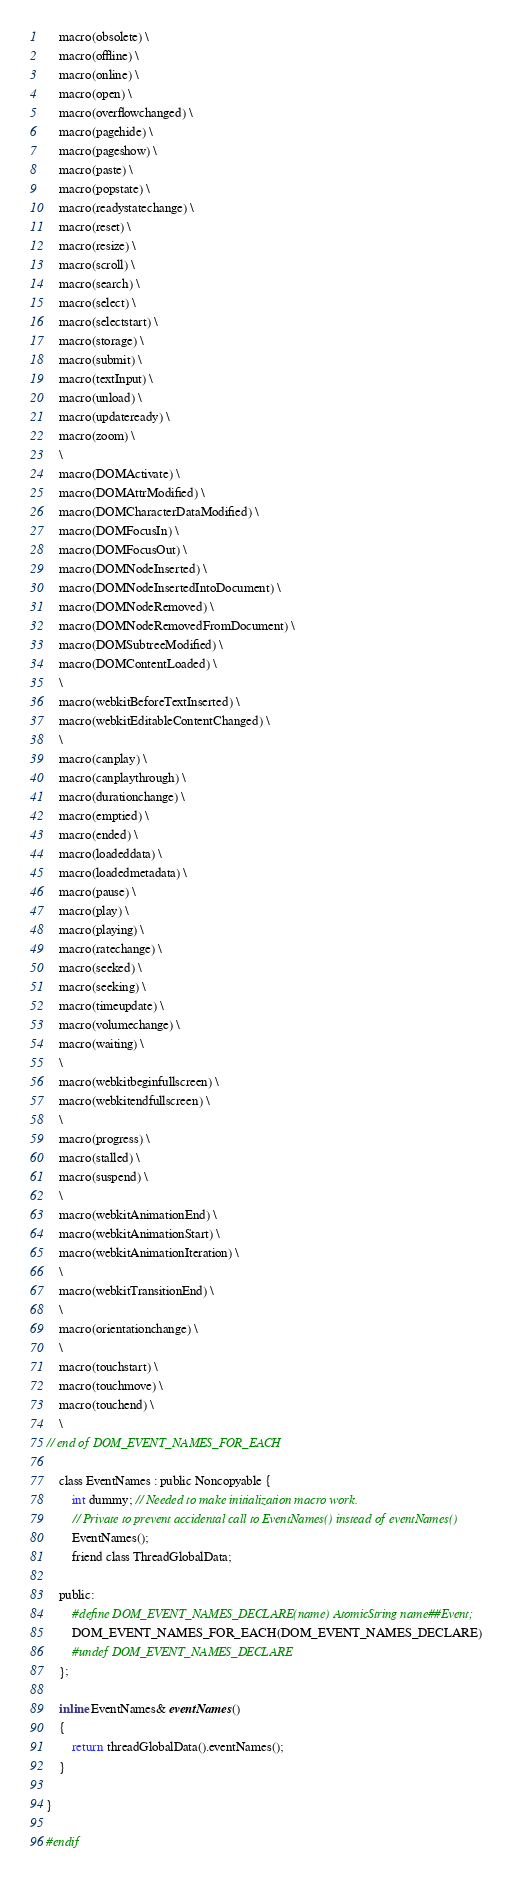<code> <loc_0><loc_0><loc_500><loc_500><_C_>    macro(obsolete) \
    macro(offline) \
    macro(online) \
    macro(open) \
    macro(overflowchanged) \
    macro(pagehide) \
    macro(pageshow) \
    macro(paste) \
    macro(popstate) \
    macro(readystatechange) \
    macro(reset) \
    macro(resize) \
    macro(scroll) \
    macro(search) \
    macro(select) \
    macro(selectstart) \
    macro(storage) \
    macro(submit) \
    macro(textInput) \
    macro(unload) \
    macro(updateready) \
    macro(zoom) \
    \
    macro(DOMActivate) \
    macro(DOMAttrModified) \
    macro(DOMCharacterDataModified) \
    macro(DOMFocusIn) \
    macro(DOMFocusOut) \
    macro(DOMNodeInserted) \
    macro(DOMNodeInsertedIntoDocument) \
    macro(DOMNodeRemoved) \
    macro(DOMNodeRemovedFromDocument) \
    macro(DOMSubtreeModified) \
    macro(DOMContentLoaded) \
    \
    macro(webkitBeforeTextInserted) \
    macro(webkitEditableContentChanged) \
    \
    macro(canplay) \
    macro(canplaythrough) \
    macro(durationchange) \
    macro(emptied) \
    macro(ended) \
    macro(loadeddata) \
    macro(loadedmetadata) \
    macro(pause) \
    macro(play) \
    macro(playing) \
    macro(ratechange) \
    macro(seeked) \
    macro(seeking) \
    macro(timeupdate) \
    macro(volumechange) \
    macro(waiting) \
    \
    macro(webkitbeginfullscreen) \
    macro(webkitendfullscreen) \
    \
    macro(progress) \
    macro(stalled) \
    macro(suspend) \
    \
    macro(webkitAnimationEnd) \
    macro(webkitAnimationStart) \
    macro(webkitAnimationIteration) \
    \
    macro(webkitTransitionEnd) \
    \
    macro(orientationchange) \
    \
    macro(touchstart) \
    macro(touchmove) \
    macro(touchend) \
    \
// end of DOM_EVENT_NAMES_FOR_EACH

    class EventNames : public Noncopyable {
        int dummy; // Needed to make initialization macro work.
        // Private to prevent accidental call to EventNames() instead of eventNames()
        EventNames();
        friend class ThreadGlobalData;

    public:
        #define DOM_EVENT_NAMES_DECLARE(name) AtomicString name##Event;
        DOM_EVENT_NAMES_FOR_EACH(DOM_EVENT_NAMES_DECLARE)
        #undef DOM_EVENT_NAMES_DECLARE
    };

    inline EventNames& eventNames()
    {
        return threadGlobalData().eventNames();
    }

}

#endif
</code> 